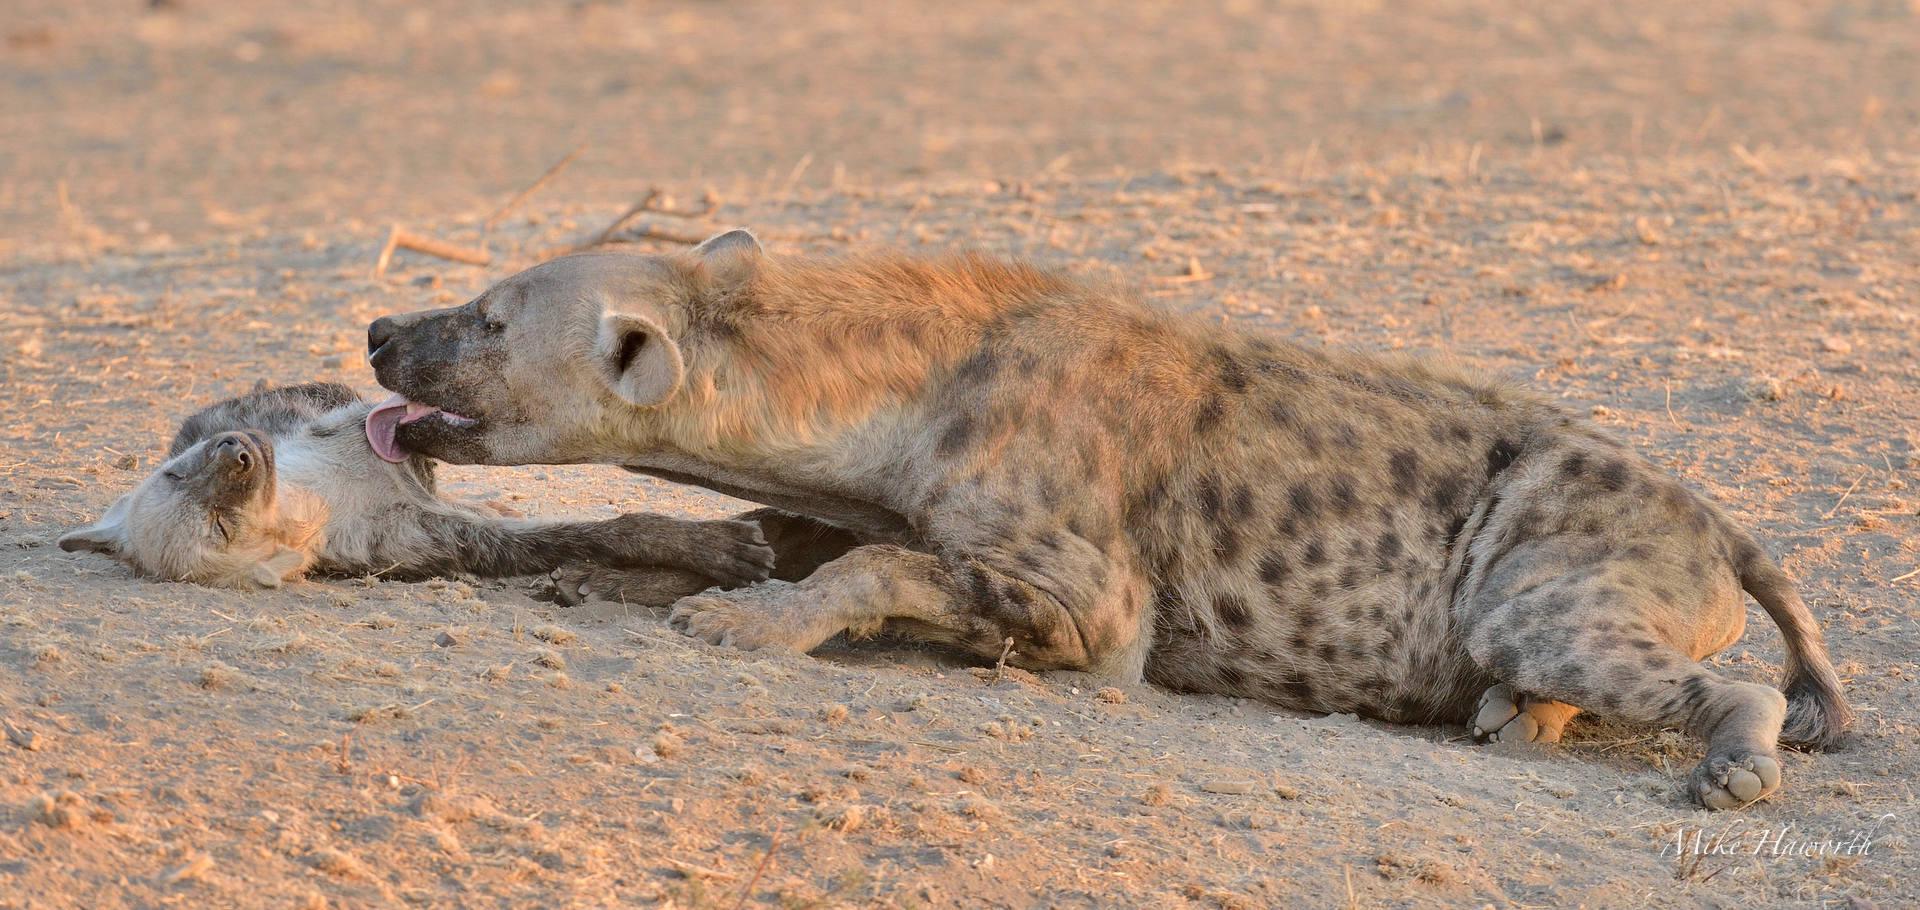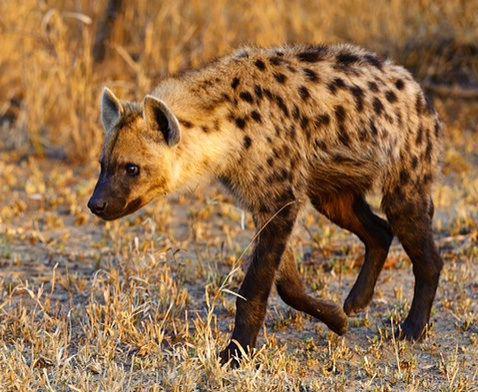The first image is the image on the left, the second image is the image on the right. Evaluate the accuracy of this statement regarding the images: "There are some lion cubs here.". Is it true? Answer yes or no. No. 